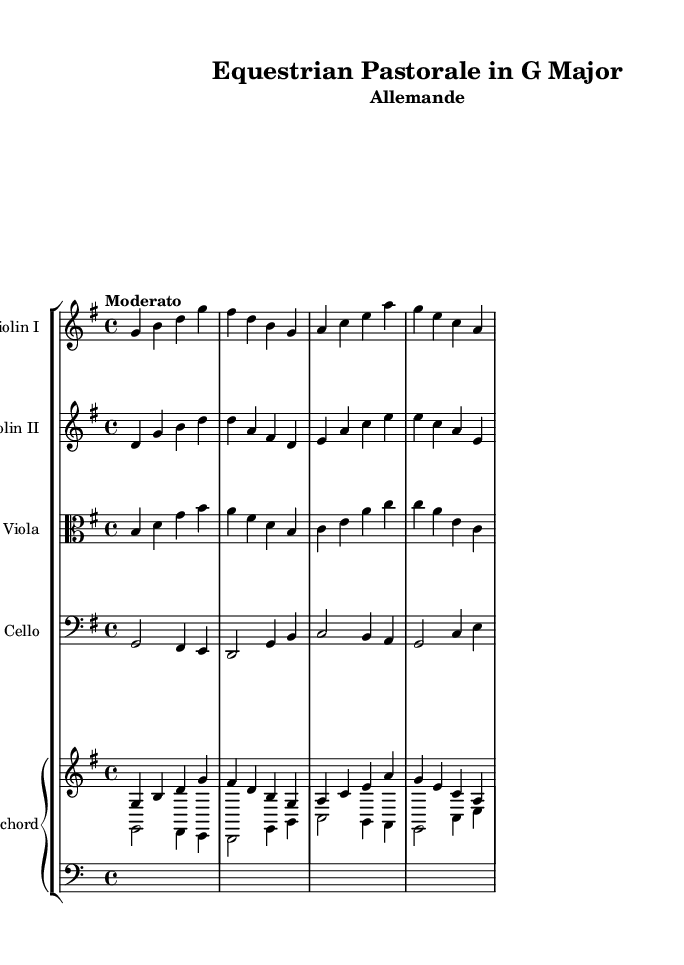What is the key signature of this music? The key signature is identified by the number of sharps or flats in the beginning of the staff. Here, there is one sharp (F#), indicating that the music is in G Major.
Answer: G Major What is the time signature of this music? The time signature is represented by the two numbers at the beginning of the piece. Here, it shows 4 over 4, meaning there are four beats per measure.
Answer: 4/4 What is the tempo marking given for this piece? The tempo marking is typically written above the staff and indicates the speed. In this case, it reads "Moderato," suggesting a moderate pace.
Answer: Moderato How many instruments are featured in the score? To find the number of instruments, count the distinct staves in the score. There are five separate staves represented, indicating five instruments (two violins, one viola, one cello, and one harpsichord).
Answer: Five Which section of the suite does this music represent? The title specifies it as "Allemande," which is a type of dance movement typically found in Baroque suites, particularly one that follows a slow and stately rhythm.
Answer: Allemande Which instrument plays the lowest part in the score? To identify the lowest part, examine the clefs used for each staff. The cello, notated in the bass clef, plays the lowest notes in this piece, below the other string instruments.
Answer: Cello What is the relationship suggested between the music and nature? The title includes "Pastorale," which indicates that the music portrays idyllic and peaceful scenes associated with nature, as well as the harmony between humans, horses, and the environment.
Answer: Pastorale 